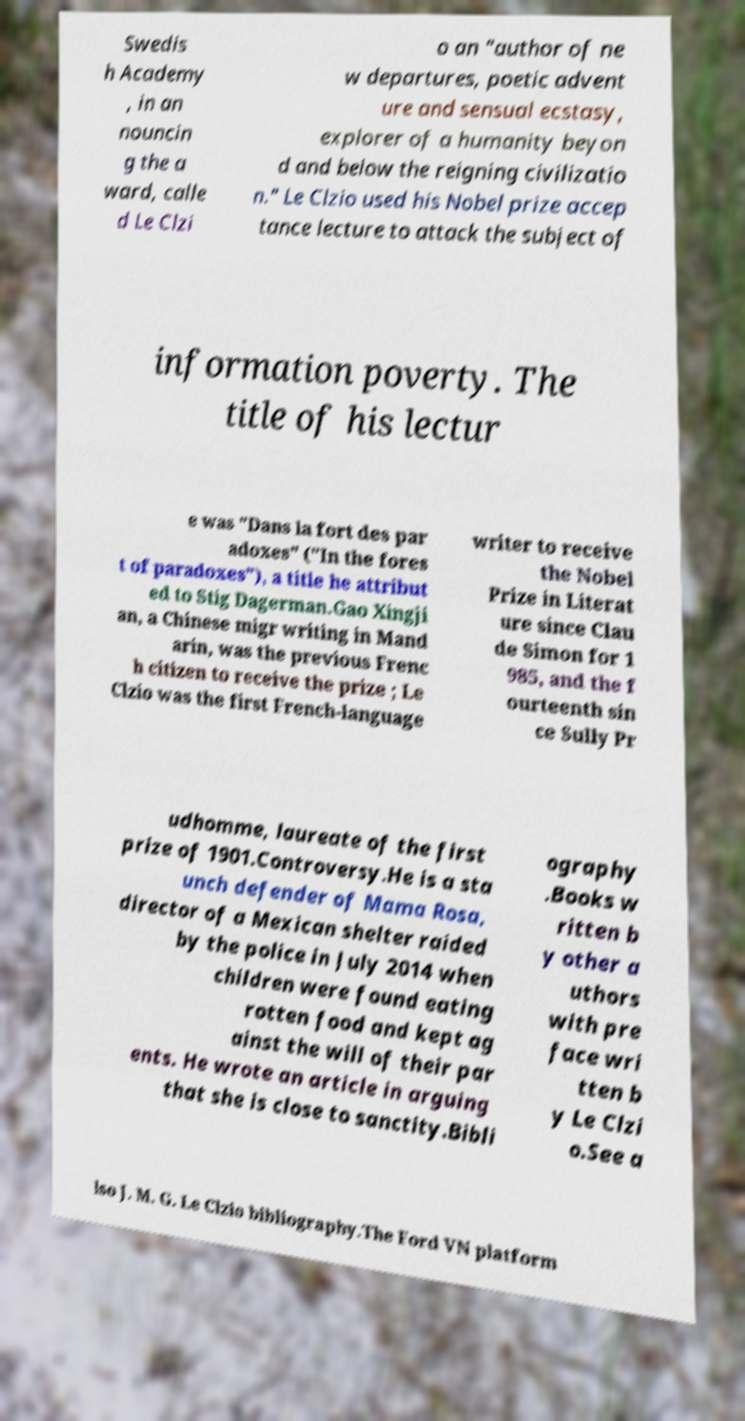There's text embedded in this image that I need extracted. Can you transcribe it verbatim? Swedis h Academy , in an nouncin g the a ward, calle d Le Clzi o an "author of ne w departures, poetic advent ure and sensual ecstasy, explorer of a humanity beyon d and below the reigning civilizatio n." Le Clzio used his Nobel prize accep tance lecture to attack the subject of information poverty. The title of his lectur e was "Dans la fort des par adoxes" ("In the fores t of paradoxes"), a title he attribut ed to Stig Dagerman.Gao Xingji an, a Chinese migr writing in Mand arin, was the previous Frenc h citizen to receive the prize ; Le Clzio was the first French-language writer to receive the Nobel Prize in Literat ure since Clau de Simon for 1 985, and the f ourteenth sin ce Sully Pr udhomme, laureate of the first prize of 1901.Controversy.He is a sta unch defender of Mama Rosa, director of a Mexican shelter raided by the police in July 2014 when children were found eating rotten food and kept ag ainst the will of their par ents. He wrote an article in arguing that she is close to sanctity.Bibli ography .Books w ritten b y other a uthors with pre face wri tten b y Le Clzi o.See a lso J. M. G. Le Clzio bibliography.The Ford VN platform 